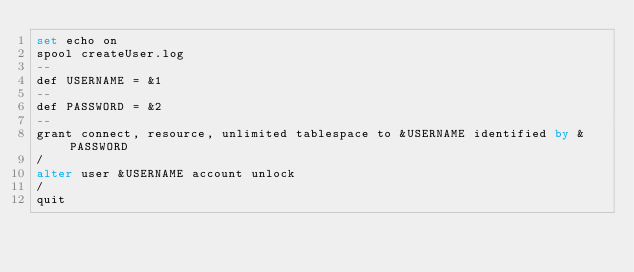<code> <loc_0><loc_0><loc_500><loc_500><_SQL_>set echo on
spool createUser.log
--
def USERNAME = &1
--
def PASSWORD = &2
--
grant connect, resource, unlimited tablespace to &USERNAME identified by &PASSWORD 
/
alter user &USERNAME account unlock
/
quit</code> 